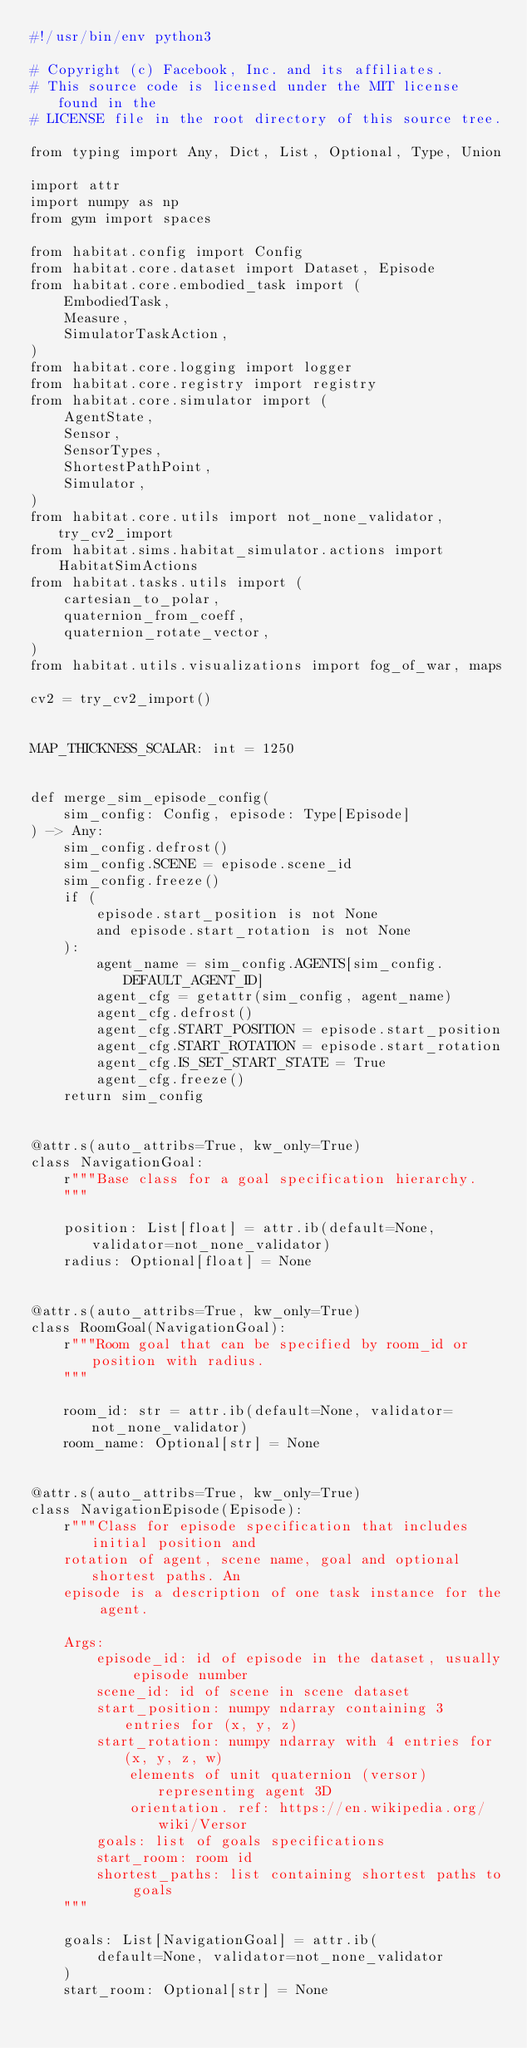<code> <loc_0><loc_0><loc_500><loc_500><_Python_>#!/usr/bin/env python3

# Copyright (c) Facebook, Inc. and its affiliates.
# This source code is licensed under the MIT license found in the
# LICENSE file in the root directory of this source tree.

from typing import Any, Dict, List, Optional, Type, Union

import attr
import numpy as np
from gym import spaces

from habitat.config import Config
from habitat.core.dataset import Dataset, Episode
from habitat.core.embodied_task import (
    EmbodiedTask,
    Measure,
    SimulatorTaskAction,
)
from habitat.core.logging import logger
from habitat.core.registry import registry
from habitat.core.simulator import (
    AgentState,
    Sensor,
    SensorTypes,
    ShortestPathPoint,
    Simulator,
)
from habitat.core.utils import not_none_validator, try_cv2_import
from habitat.sims.habitat_simulator.actions import HabitatSimActions
from habitat.tasks.utils import (
    cartesian_to_polar,
    quaternion_from_coeff,
    quaternion_rotate_vector,
)
from habitat.utils.visualizations import fog_of_war, maps

cv2 = try_cv2_import()


MAP_THICKNESS_SCALAR: int = 1250


def merge_sim_episode_config(
    sim_config: Config, episode: Type[Episode]
) -> Any:
    sim_config.defrost()
    sim_config.SCENE = episode.scene_id
    sim_config.freeze()
    if (
        episode.start_position is not None
        and episode.start_rotation is not None
    ):
        agent_name = sim_config.AGENTS[sim_config.DEFAULT_AGENT_ID]
        agent_cfg = getattr(sim_config, agent_name)
        agent_cfg.defrost()
        agent_cfg.START_POSITION = episode.start_position
        agent_cfg.START_ROTATION = episode.start_rotation
        agent_cfg.IS_SET_START_STATE = True
        agent_cfg.freeze()
    return sim_config


@attr.s(auto_attribs=True, kw_only=True)
class NavigationGoal:
    r"""Base class for a goal specification hierarchy.
    """

    position: List[float] = attr.ib(default=None, validator=not_none_validator)
    radius: Optional[float] = None


@attr.s(auto_attribs=True, kw_only=True)
class RoomGoal(NavigationGoal):
    r"""Room goal that can be specified by room_id or position with radius.
    """

    room_id: str = attr.ib(default=None, validator=not_none_validator)
    room_name: Optional[str] = None


@attr.s(auto_attribs=True, kw_only=True)
class NavigationEpisode(Episode):
    r"""Class for episode specification that includes initial position and
    rotation of agent, scene name, goal and optional shortest paths. An
    episode is a description of one task instance for the agent.

    Args:
        episode_id: id of episode in the dataset, usually episode number
        scene_id: id of scene in scene dataset
        start_position: numpy ndarray containing 3 entries for (x, y, z)
        start_rotation: numpy ndarray with 4 entries for (x, y, z, w)
            elements of unit quaternion (versor) representing agent 3D
            orientation. ref: https://en.wikipedia.org/wiki/Versor
        goals: list of goals specifications
        start_room: room id
        shortest_paths: list containing shortest paths to goals
    """

    goals: List[NavigationGoal] = attr.ib(
        default=None, validator=not_none_validator
    )
    start_room: Optional[str] = None</code> 